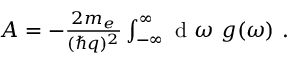Convert formula to latex. <formula><loc_0><loc_0><loc_500><loc_500>\begin{array} { r } { A = - \frac { 2 m _ { e } } { ( \hbar { q } ) ^ { 2 } } \int _ { - \infty } ^ { \infty } d \omega \ g ( \omega ) \ . } \end{array}</formula> 